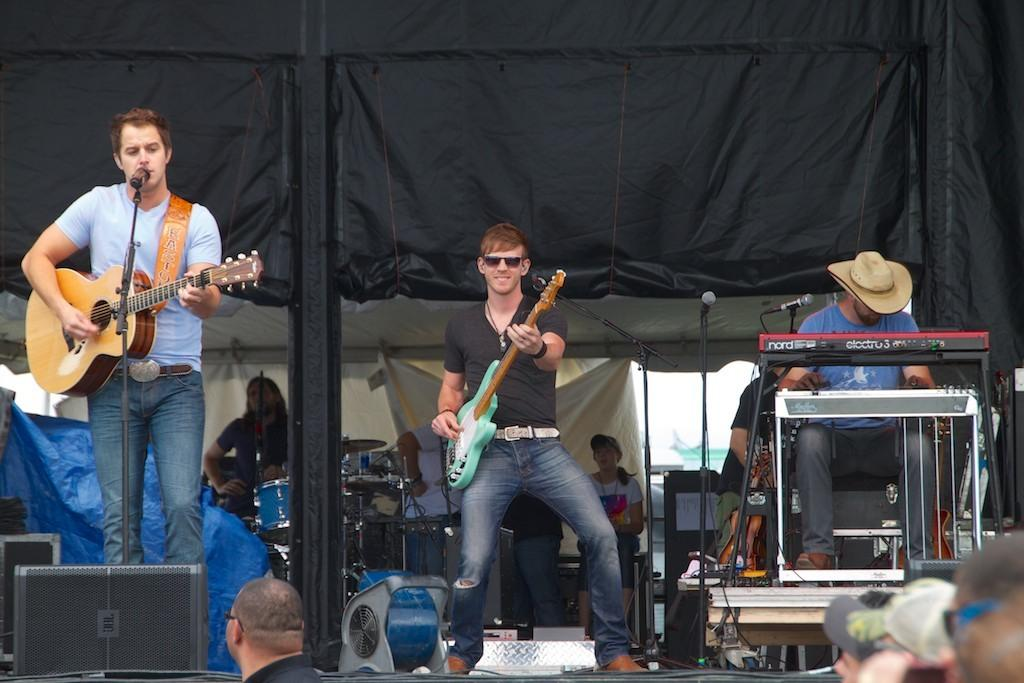What is the man in the image doing with the guitar? The man in the image is playing the guitar. What other activity is the man engaged in? The man is also singing in the image. What object is present that might be used for amplifying the man's voice? There is a microphone in the image. What is the other man in the image doing? The other man is dancing in the middle of the image. What type of straw is being used by the man playing the guitar in the image? There is no straw present in the image; the man is playing the guitar and singing. 